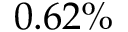Convert formula to latex. <formula><loc_0><loc_0><loc_500><loc_500>0 . 6 2 \%</formula> 